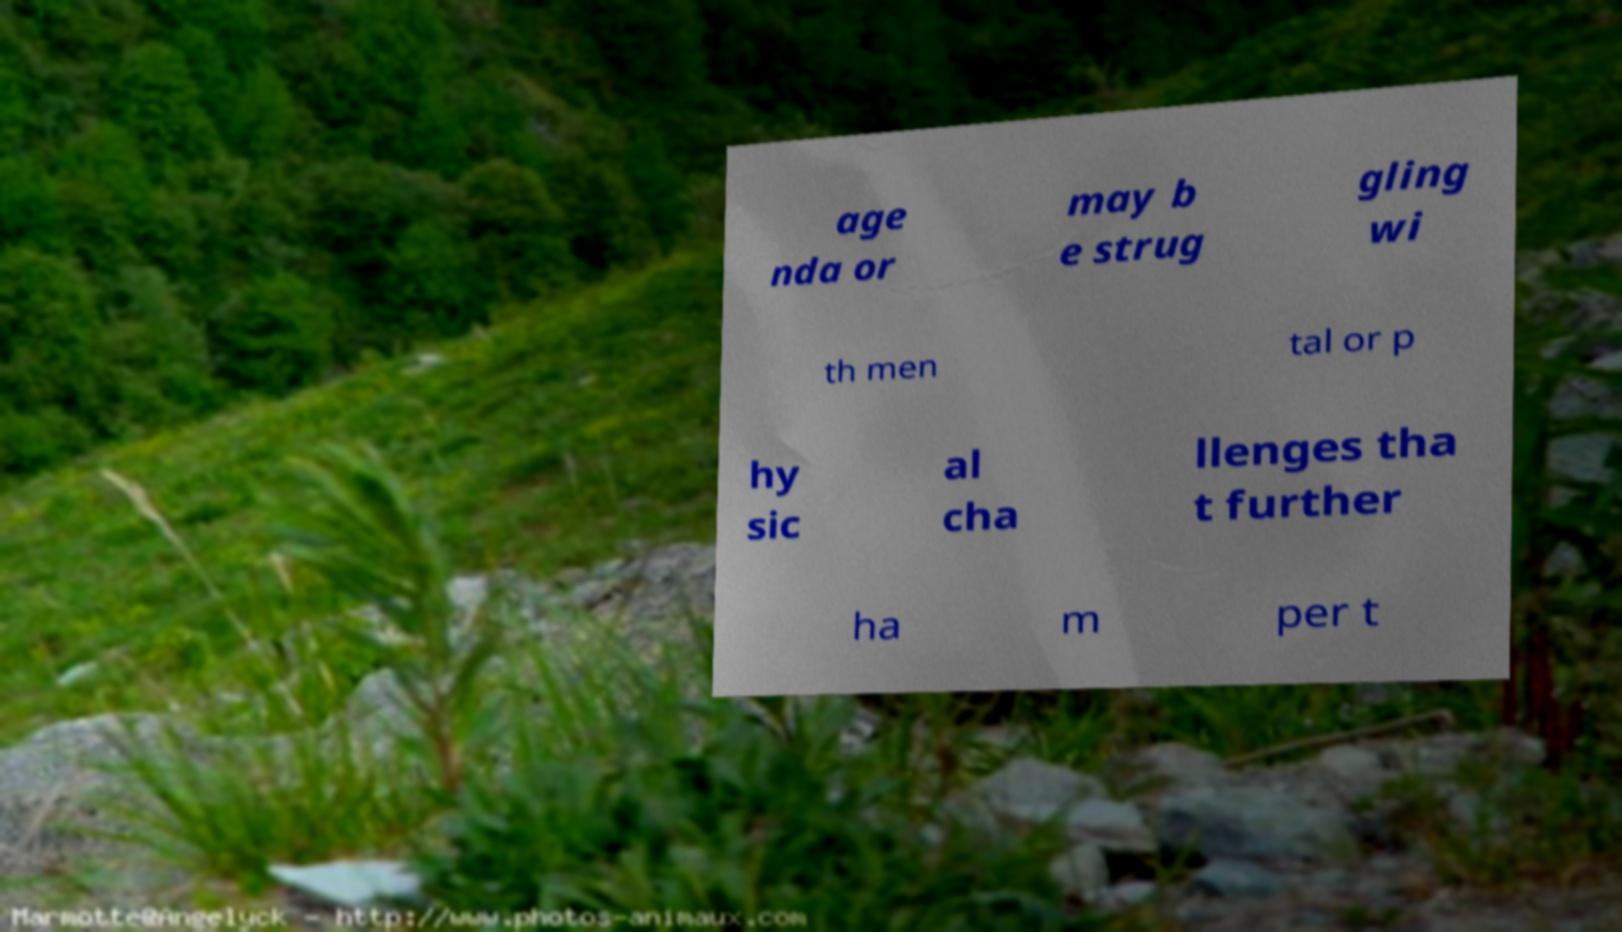Could you assist in decoding the text presented in this image and type it out clearly? age nda or may b e strug gling wi th men tal or p hy sic al cha llenges tha t further ha m per t 